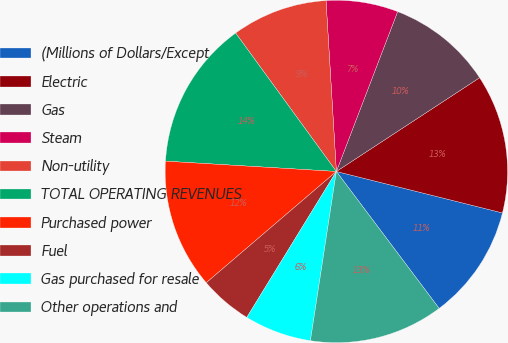<chart> <loc_0><loc_0><loc_500><loc_500><pie_chart><fcel>(Millions of Dollars/Except<fcel>Electric<fcel>Gas<fcel>Steam<fcel>Non-utility<fcel>TOTAL OPERATING REVENUES<fcel>Purchased power<fcel>Fuel<fcel>Gas purchased for resale<fcel>Other operations and<nl><fcel>10.86%<fcel>13.12%<fcel>9.95%<fcel>6.79%<fcel>9.05%<fcel>14.03%<fcel>12.22%<fcel>4.98%<fcel>6.34%<fcel>12.67%<nl></chart> 